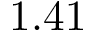<formula> <loc_0><loc_0><loc_500><loc_500>1 . 4 1</formula> 